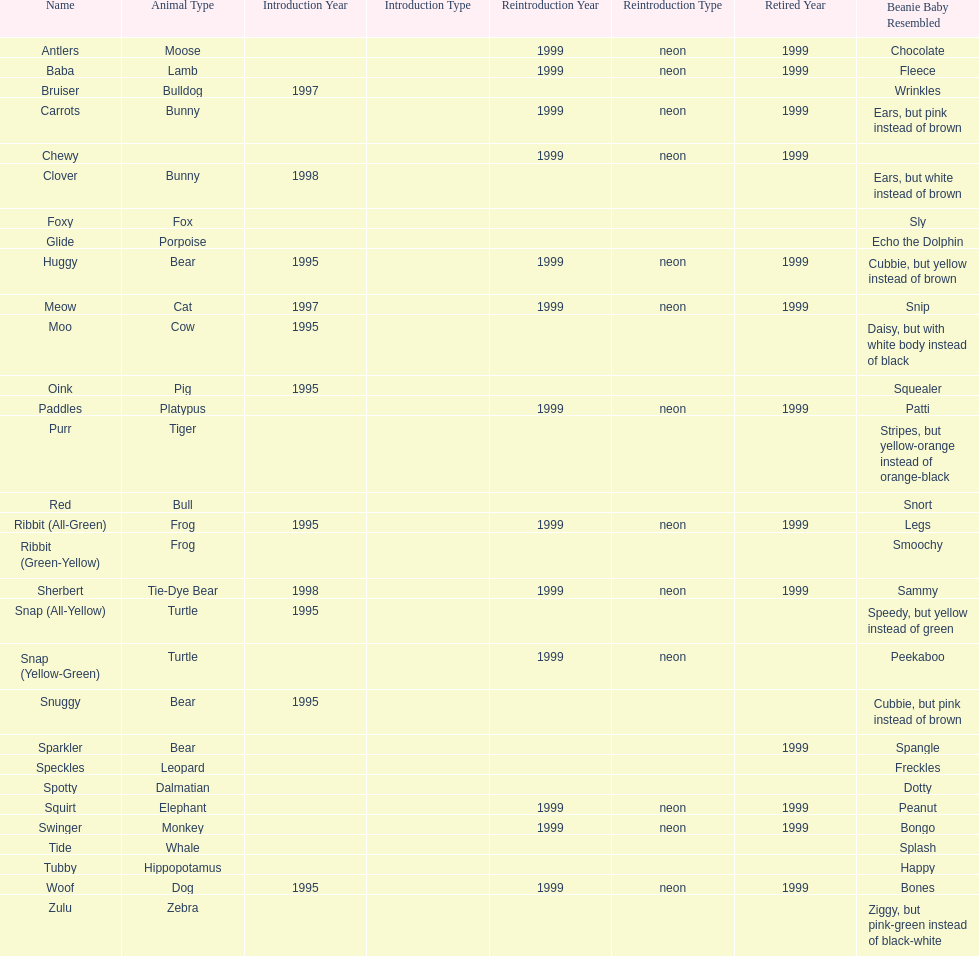What is the name of the last pillow pal on this chart? Zulu. 